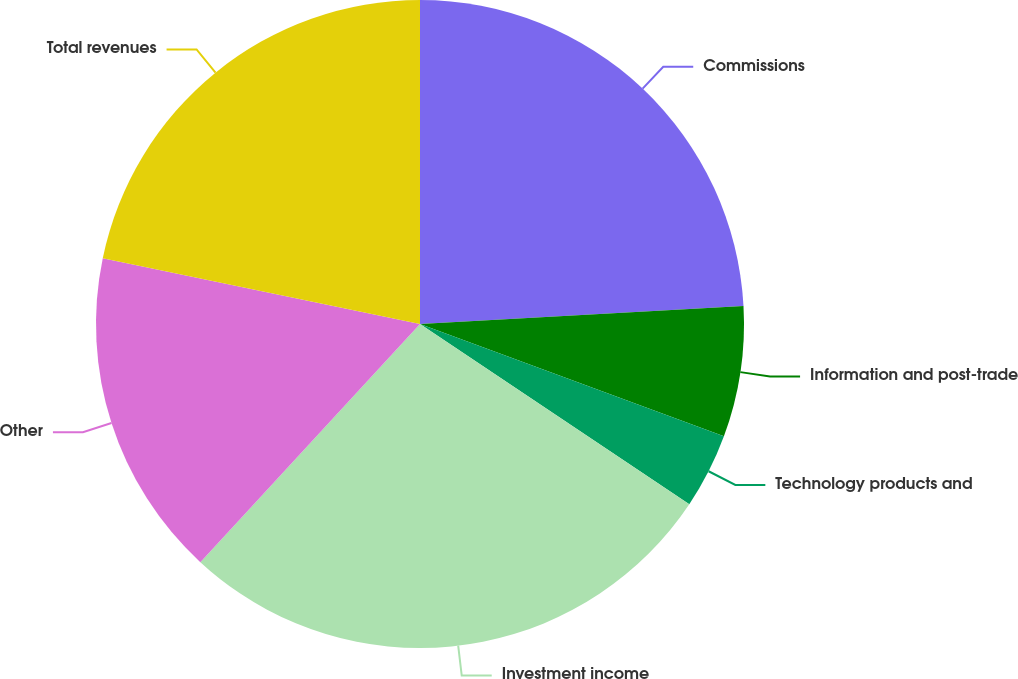Convert chart. <chart><loc_0><loc_0><loc_500><loc_500><pie_chart><fcel>Commissions<fcel>Information and post-trade<fcel>Technology products and<fcel>Investment income<fcel>Other<fcel>Total revenues<nl><fcel>24.11%<fcel>6.52%<fcel>3.75%<fcel>27.47%<fcel>16.4%<fcel>21.74%<nl></chart> 